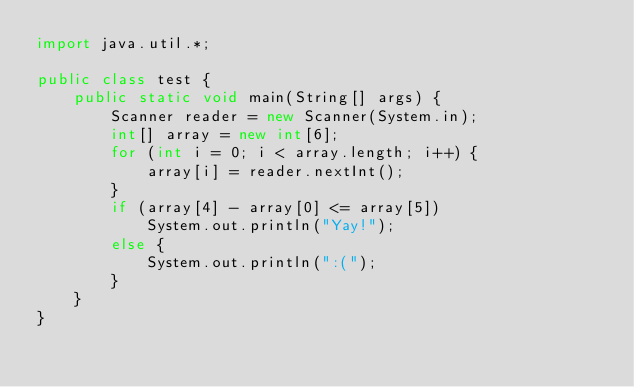Convert code to text. <code><loc_0><loc_0><loc_500><loc_500><_Java_>import java.util.*;

public class test {
    public static void main(String[] args) {
        Scanner reader = new Scanner(System.in);
        int[] array = new int[6];
        for (int i = 0; i < array.length; i++) {
            array[i] = reader.nextInt();
        }
        if (array[4] - array[0] <= array[5])
            System.out.println("Yay!");
        else {
            System.out.println(":(");
        }
    }
}</code> 